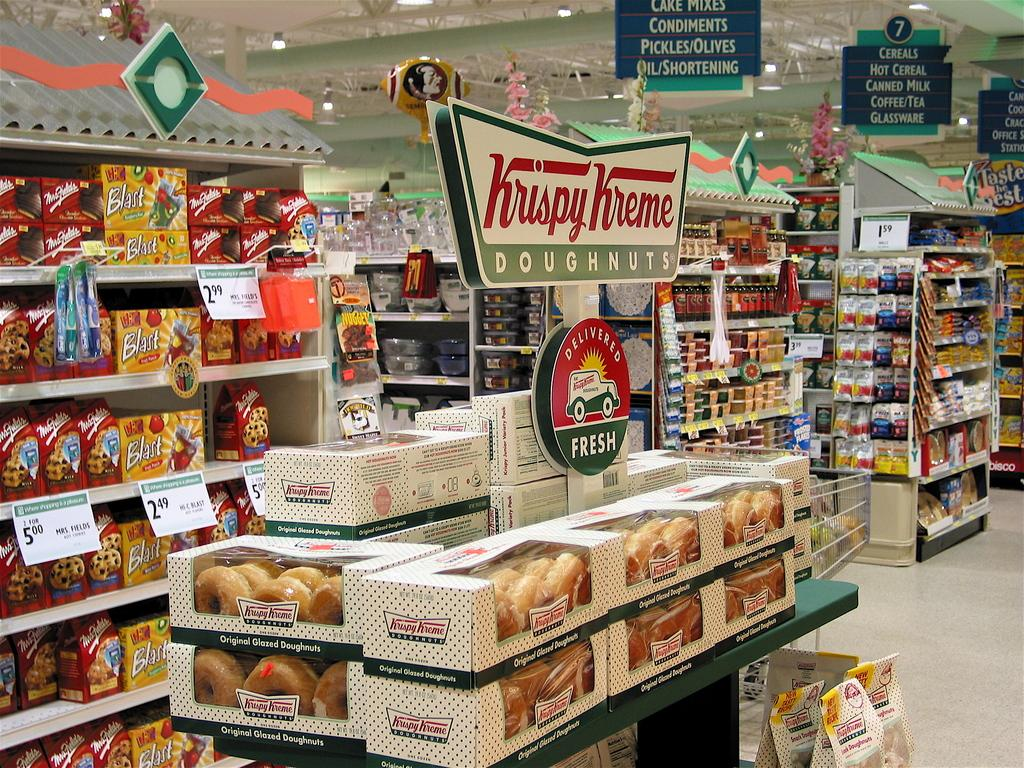What is the primary surface visible in the image? There is a floor in the image. What type of storage units are present in the image? There are racks in the image. What can be found inside the racks? There are objects in the racks. What type of material is used for the boards in the image? The information provided does not specify the material of the boards. What is located above the racks and objects in the image? There is a ceiling in the image. What type of structural elements are present in the image? There are metal rods in the image. What provides illumination in the image? There are lights attached to the ceiling in the image. What type of bottle is being used as a quilt by the team in the image? There is no bottle, quilt, or team present in the image. 